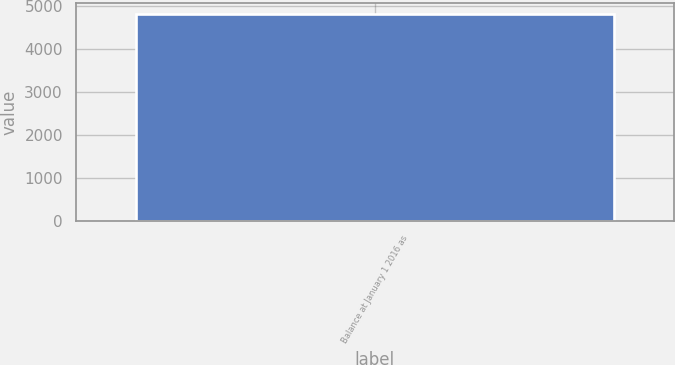<chart> <loc_0><loc_0><loc_500><loc_500><bar_chart><fcel>Balance at January 1 2016 as<nl><fcel>4834.1<nl></chart> 